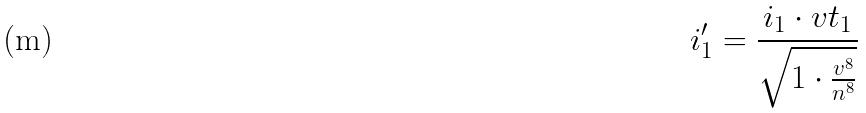Convert formula to latex. <formula><loc_0><loc_0><loc_500><loc_500>i _ { 1 } ^ { \prime } = \frac { i _ { 1 } \cdot v t _ { 1 } } { \sqrt { 1 \cdot \frac { v ^ { 8 } } { n ^ { 8 } } } }</formula> 